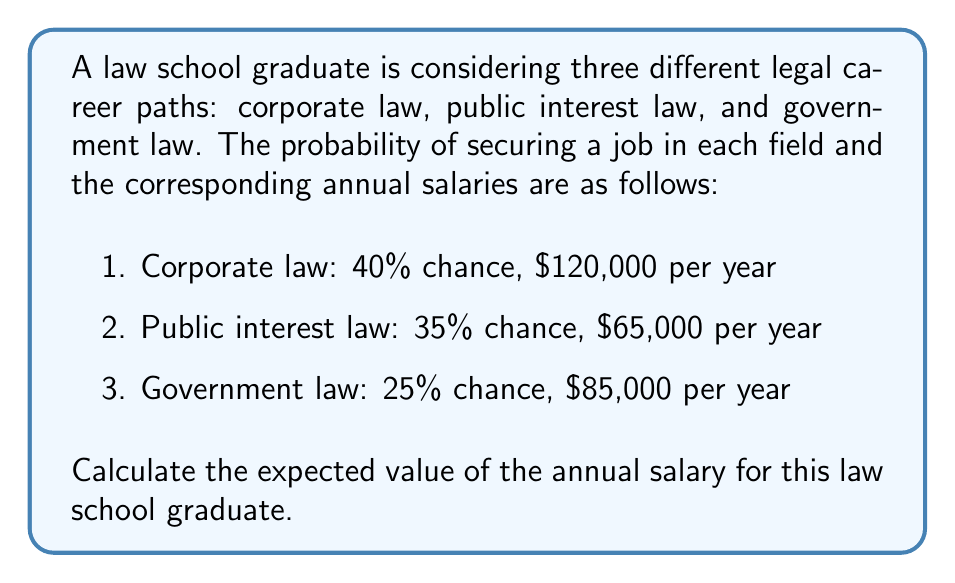Can you answer this question? To calculate the expected value of the annual salary, we need to follow these steps:

1. Multiply each potential salary by its corresponding probability.
2. Sum up all the resulting values.

Let's calculate for each career path:

1. Corporate law:
   $P(\text{Corporate}) \times \text{Salary}_{\text{Corporate}} = 0.40 \times \$120,000 = \$48,000$

2. Public interest law:
   $P(\text{Public Interest}) \times \text{Salary}_{\text{Public Interest}} = 0.35 \times \$65,000 = \$22,750$

3. Government law:
   $P(\text{Government}) \times \text{Salary}_{\text{Government}} = 0.25 \times \$85,000 = \$21,250$

Now, we sum up these values to get the expected value:

$$\begin{align*}
E(\text{Salary}) &= \$48,000 + \$22,750 + \$21,250 \\
&= \$92,000
\end{align*}$$

Therefore, the expected value of the annual salary for this law school graduate is $92,000.
Answer: $92,000 